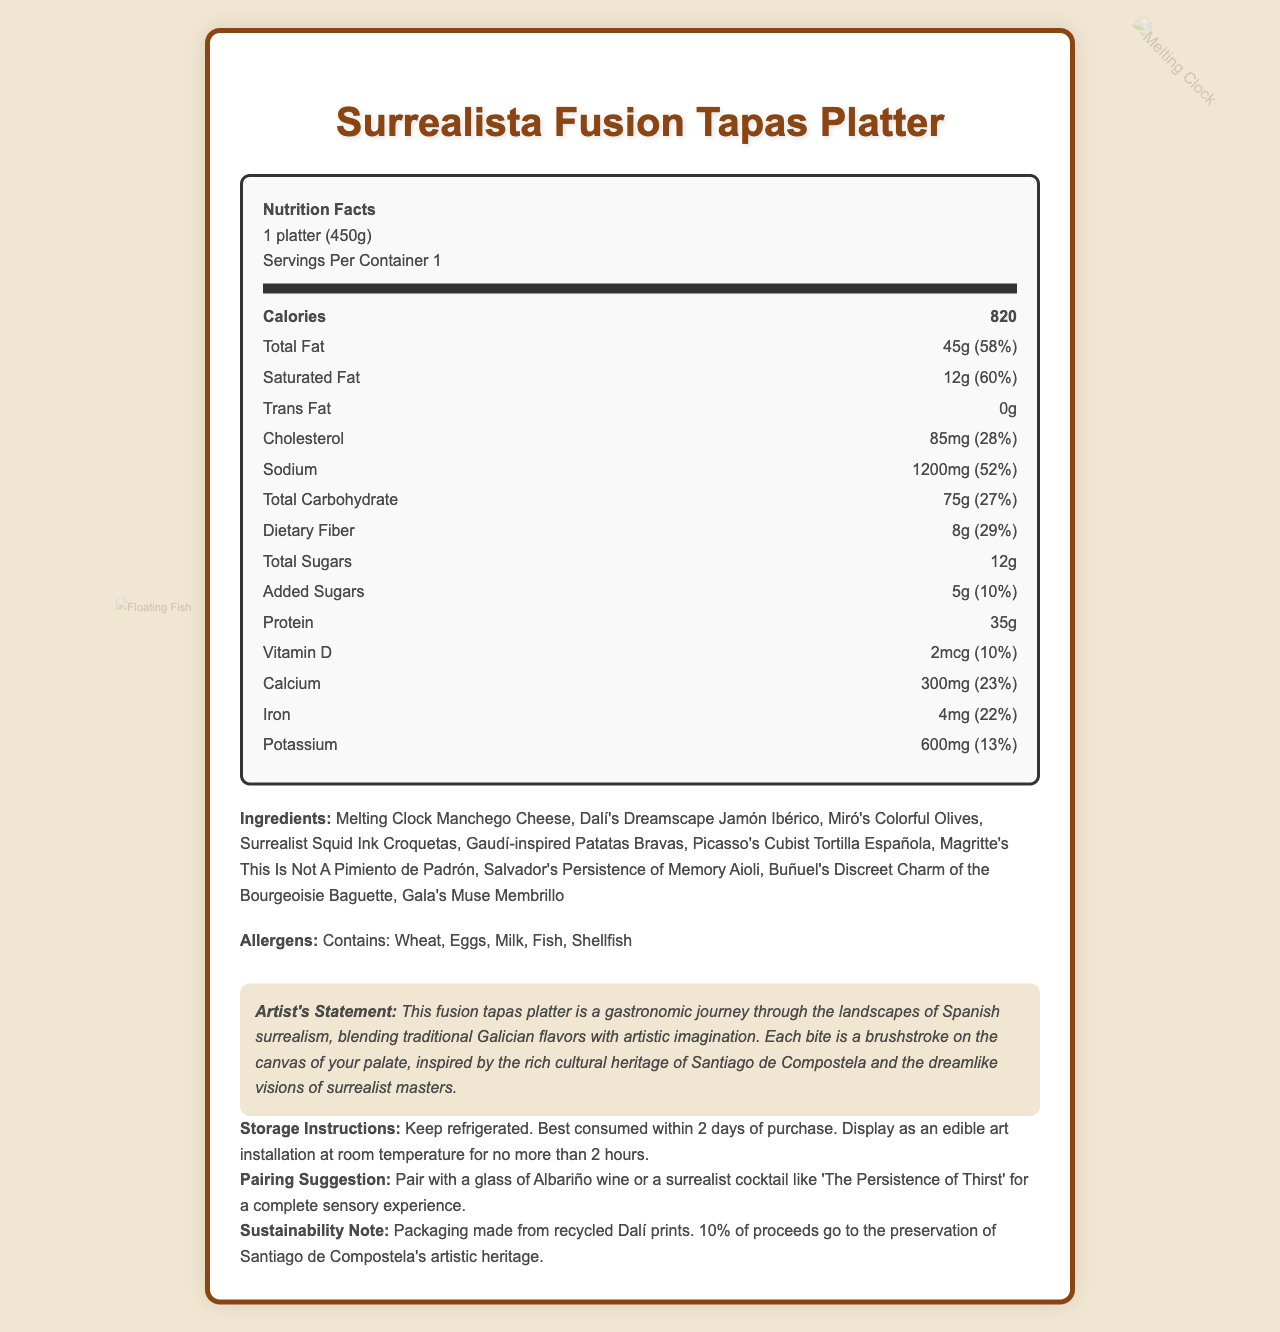who is the artist behind the fusion tapas platter concept? The document does not provide information about the specific artist who conceptualized the Surrealista Fusion Tapas Platter.
Answer: Not enough information what is the serving size of the Surrealista Fusion Tapas Platter? The serving size is explicitly stated in the document under the 'Nutrition Facts' section: "1 platter (450g)".
Answer: 1 platter (450g) how many calories are in one serving of the Surrealista Fusion Tapas Platter? The document states that each serving, which is one platter, contains 820 calories.
Answer: 820 calories which ingredient listed is inspired by Picasso? The document lists "Picasso's Cubist Tortilla Española" as one of the ingredients.
Answer: Cubist Tortilla Española what is the total fat content in the Surrealista Fusion Tapas Platter? The 'Nutrition Facts' section indicates that the total fat content is 45g, which is 58% of the daily value.
Answer: 45g (58% Daily Value) what are the allergens present in the Surrealista Fusion Tapas Platter? These allergens are explicitly listed in the document under the "Allergens" section.
Answer: Wheat, Eggs, Milk, Fish, Shellfish how much protein does the Surrealista Fusion Tapas Platter contain? The document states that the platter contains 35g of protein.
Answer: 35g what is the daily value percentage of dietary fiber in the Surrealista Fusion Tapas Platter? The document's 'Nutrition Facts' section notes that the daily value percentage of dietary fiber is 29%.
Answer: 29% which of the following ingredients is suggested as a pairing with the platter? A. Albariño wine B. Rioja wine C. Sangria D. Sherry The "Pairing Suggestion" section of the document suggests pairing the platter with a glass of Albariño wine or a surrealist cocktail like 'The Persistence of Thirst'.
Answer: A. Albariño wine how many credits of iron are present in the fusion tapas platter? i. 1mg ii. 2mg iii. 3mg iv. 4mg The 'Nutrition Facts' section lists the amount of iron as 4mg and its daily value percentage as 22%.
Answer: iv. 4mg is the Surrealista Fusion Tapas Platter suitable for someone with a shellfish allergy? The document lists shellfish as one of the allergens present in the platter.
Answer: No summarize the main idea of the document The document represents a blend of art and cuisine, showcasing a tapas platter inspired by famous surrealist artists. It highlights its nutritional content, lists allergens, and emphasizes the artistic inspiration behind each ingredient. Additionally, it provides practical information on storage and pairing, along with an artist statement expressing the fusion of gastronomy and Surrealism.
Answer: The Surrealista Fusion Tapas Platter combines traditional Galician flavors with elements of Surrealism, resulting in a unique culinary creation inspired by Spanish surrealist art. It provides detailed nutritional information, ingredients, allergens, and special features like an artist's statement, storage instructions, and pairing suggestions. what inspired the Melting Clock Manchego Cheese? The document lists the ingredient as "Melting Clock Manchego Cheese," which is a direct reference to Salvador Dalí's famous melting clocks from his surrealist paintings.
Answer: Surrealism what percentage of proceeds is allocated to the preservation of Santiago de Compostela's artistic heritage? The "Sustainability Note" section mentions that 10% of the proceeds go towards the preservation of Santiago de Compostela's artistic heritage.
Answer: 10% how long can the Surrealista Fusion Tapas Platter be displayed at room temperature? The "Storage Instructions" section states that the platter should be displayed as an edible art installation at room temperature for no more than 2 hours.
Answer: No more than 2 hours does the Surrealista Fusion Tapas Platter contain any added sugars? According to the 'Nutrition Facts' section, the platter contains 5g of added sugars, which is 10% of the daily value.
Answer: Yes 